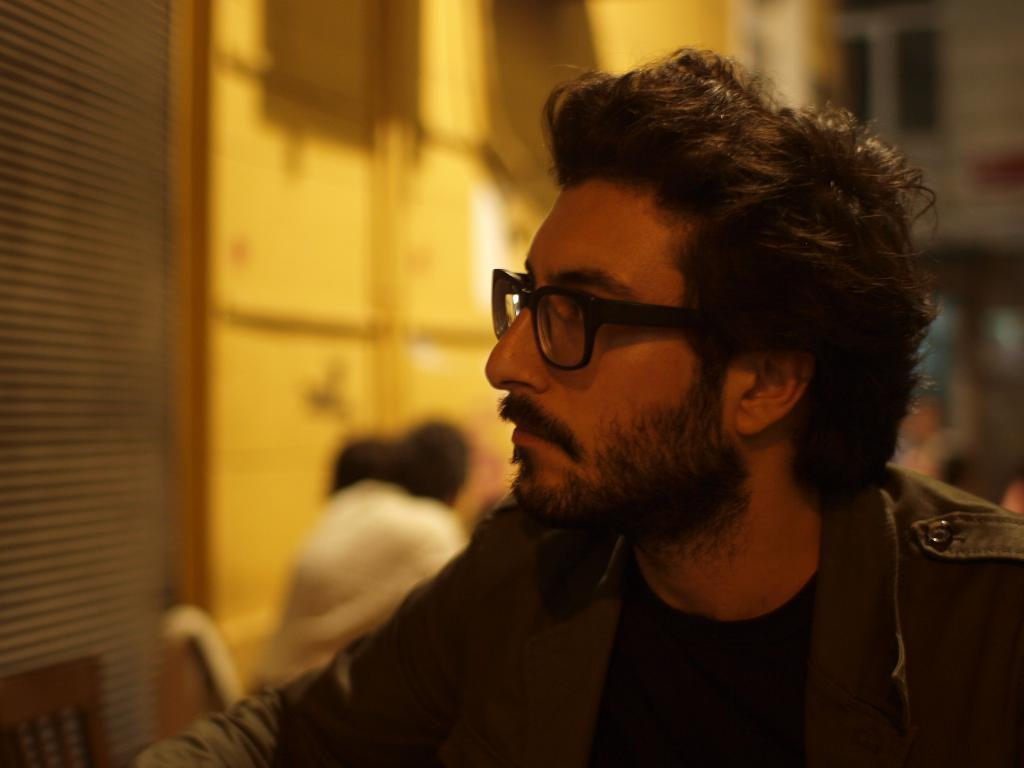Who is present in the image? There is a man in the image. What is the man wearing in the image? The man is wearing a jacket and spectacles in the image. Can you describe the background of the image? The background of the image is blurred. What type of verse can be heard being recited by the man in the image? There is no indication in the image that the man is reciting a verse, so it cannot be determined from the picture. 